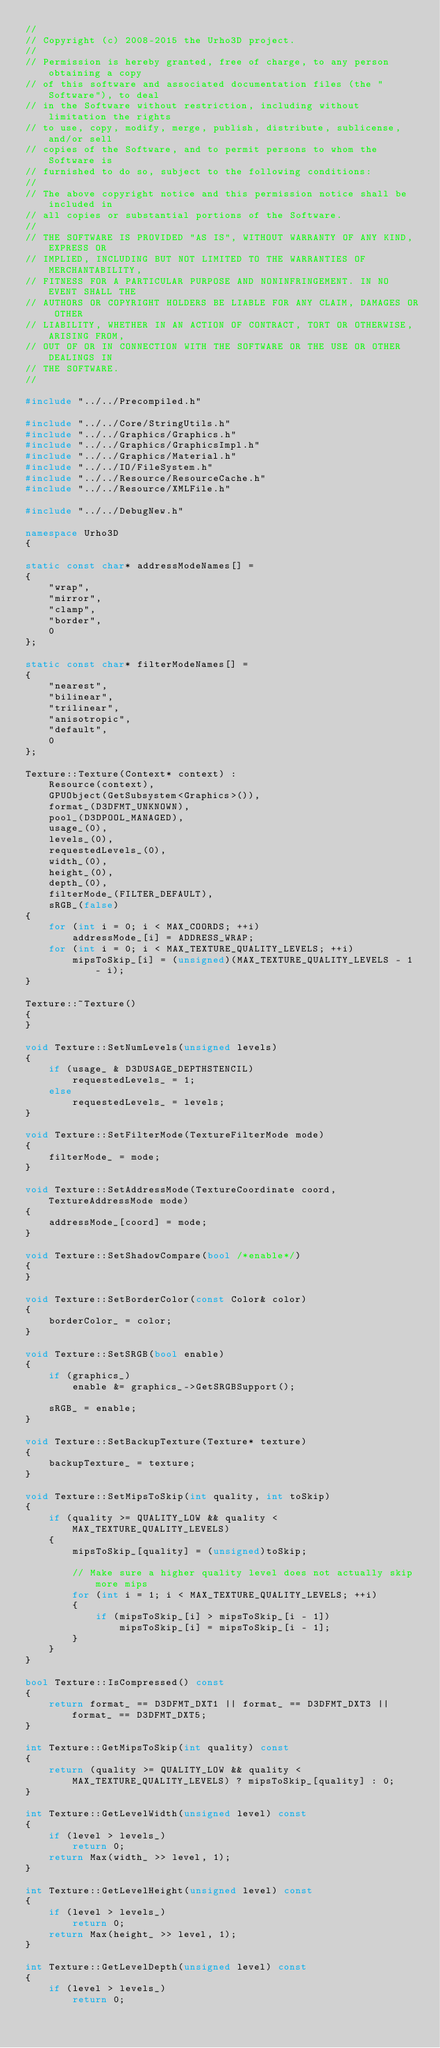Convert code to text. <code><loc_0><loc_0><loc_500><loc_500><_C++_>//
// Copyright (c) 2008-2015 the Urho3D project.
//
// Permission is hereby granted, free of charge, to any person obtaining a copy
// of this software and associated documentation files (the "Software"), to deal
// in the Software without restriction, including without limitation the rights
// to use, copy, modify, merge, publish, distribute, sublicense, and/or sell
// copies of the Software, and to permit persons to whom the Software is
// furnished to do so, subject to the following conditions:
//
// The above copyright notice and this permission notice shall be included in
// all copies or substantial portions of the Software.
//
// THE SOFTWARE IS PROVIDED "AS IS", WITHOUT WARRANTY OF ANY KIND, EXPRESS OR
// IMPLIED, INCLUDING BUT NOT LIMITED TO THE WARRANTIES OF MERCHANTABILITY,
// FITNESS FOR A PARTICULAR PURPOSE AND NONINFRINGEMENT. IN NO EVENT SHALL THE
// AUTHORS OR COPYRIGHT HOLDERS BE LIABLE FOR ANY CLAIM, DAMAGES OR OTHER
// LIABILITY, WHETHER IN AN ACTION OF CONTRACT, TORT OR OTHERWISE, ARISING FROM,
// OUT OF OR IN CONNECTION WITH THE SOFTWARE OR THE USE OR OTHER DEALINGS IN
// THE SOFTWARE.
//

#include "../../Precompiled.h"

#include "../../Core/StringUtils.h"
#include "../../Graphics/Graphics.h"
#include "../../Graphics/GraphicsImpl.h"
#include "../../Graphics/Material.h"
#include "../../IO/FileSystem.h"
#include "../../Resource/ResourceCache.h"
#include "../../Resource/XMLFile.h"

#include "../../DebugNew.h"

namespace Urho3D
{

static const char* addressModeNames[] =
{
    "wrap",
    "mirror",
    "clamp",
    "border",
    0
};

static const char* filterModeNames[] =
{
    "nearest",
    "bilinear",
    "trilinear",
    "anisotropic",
    "default",
    0
};

Texture::Texture(Context* context) :
    Resource(context),
    GPUObject(GetSubsystem<Graphics>()),
    format_(D3DFMT_UNKNOWN),
    pool_(D3DPOOL_MANAGED),
    usage_(0),
    levels_(0),
    requestedLevels_(0),
    width_(0),
    height_(0),
    depth_(0),
    filterMode_(FILTER_DEFAULT),
    sRGB_(false)
{
    for (int i = 0; i < MAX_COORDS; ++i)
        addressMode_[i] = ADDRESS_WRAP;
    for (int i = 0; i < MAX_TEXTURE_QUALITY_LEVELS; ++i)
        mipsToSkip_[i] = (unsigned)(MAX_TEXTURE_QUALITY_LEVELS - 1 - i);
}

Texture::~Texture()
{
}

void Texture::SetNumLevels(unsigned levels)
{
    if (usage_ & D3DUSAGE_DEPTHSTENCIL)
        requestedLevels_ = 1;
    else
        requestedLevels_ = levels;
}

void Texture::SetFilterMode(TextureFilterMode mode)
{
    filterMode_ = mode;
}

void Texture::SetAddressMode(TextureCoordinate coord, TextureAddressMode mode)
{
    addressMode_[coord] = mode;
}

void Texture::SetShadowCompare(bool /*enable*/)
{
}

void Texture::SetBorderColor(const Color& color)
{
    borderColor_ = color;
}

void Texture::SetSRGB(bool enable)
{
    if (graphics_)
        enable &= graphics_->GetSRGBSupport();

    sRGB_ = enable;
}

void Texture::SetBackupTexture(Texture* texture)
{
    backupTexture_ = texture;
}

void Texture::SetMipsToSkip(int quality, int toSkip)
{
    if (quality >= QUALITY_LOW && quality < MAX_TEXTURE_QUALITY_LEVELS)
    {
        mipsToSkip_[quality] = (unsigned)toSkip;

        // Make sure a higher quality level does not actually skip more mips
        for (int i = 1; i < MAX_TEXTURE_QUALITY_LEVELS; ++i)
        {
            if (mipsToSkip_[i] > mipsToSkip_[i - 1])
                mipsToSkip_[i] = mipsToSkip_[i - 1];
        }
    }
}

bool Texture::IsCompressed() const
{
    return format_ == D3DFMT_DXT1 || format_ == D3DFMT_DXT3 || format_ == D3DFMT_DXT5;
}

int Texture::GetMipsToSkip(int quality) const
{
    return (quality >= QUALITY_LOW && quality < MAX_TEXTURE_QUALITY_LEVELS) ? mipsToSkip_[quality] : 0;
}

int Texture::GetLevelWidth(unsigned level) const
{
    if (level > levels_)
        return 0;
    return Max(width_ >> level, 1);
}

int Texture::GetLevelHeight(unsigned level) const
{
    if (level > levels_)
        return 0;
    return Max(height_ >> level, 1);
}

int Texture::GetLevelDepth(unsigned level) const
{
    if (level > levels_)
        return 0;</code> 